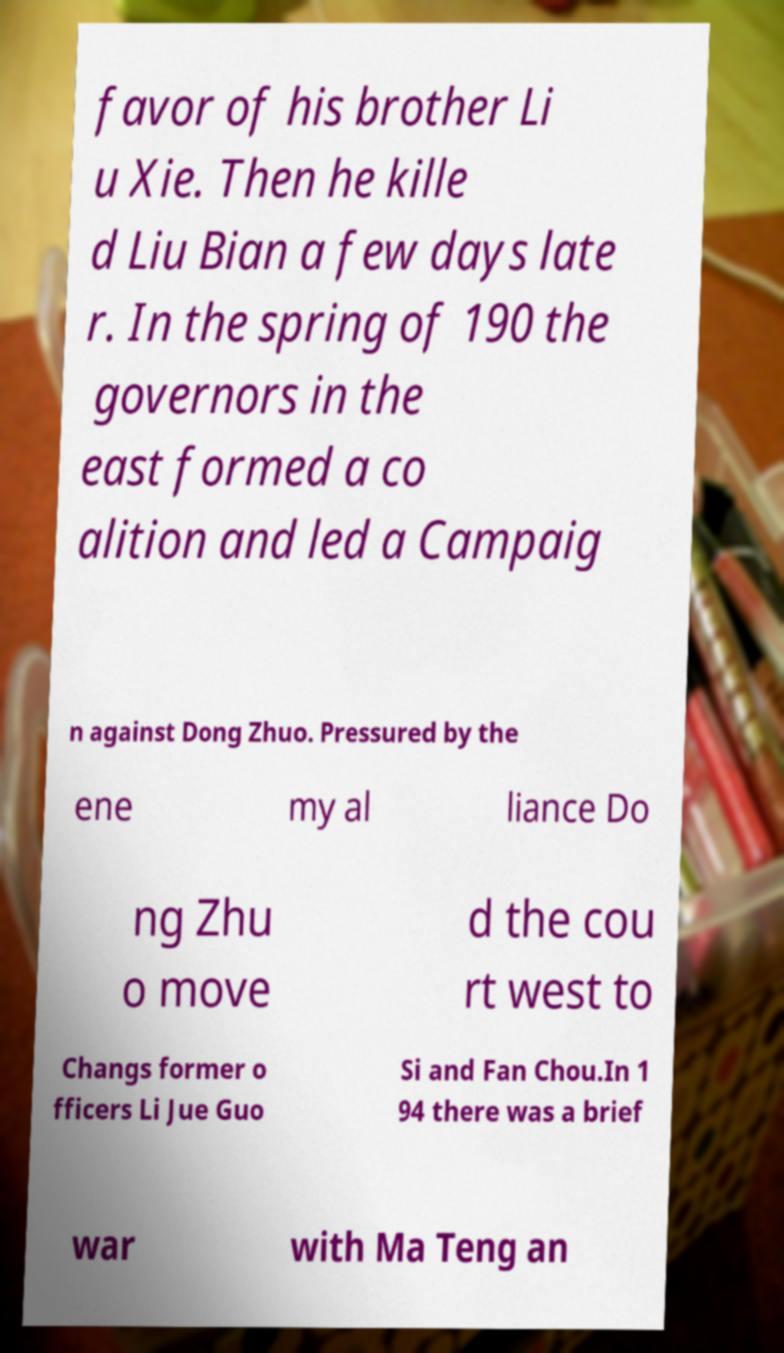I need the written content from this picture converted into text. Can you do that? favor of his brother Li u Xie. Then he kille d Liu Bian a few days late r. In the spring of 190 the governors in the east formed a co alition and led a Campaig n against Dong Zhuo. Pressured by the ene my al liance Do ng Zhu o move d the cou rt west to Changs former o fficers Li Jue Guo Si and Fan Chou.In 1 94 there was a brief war with Ma Teng an 